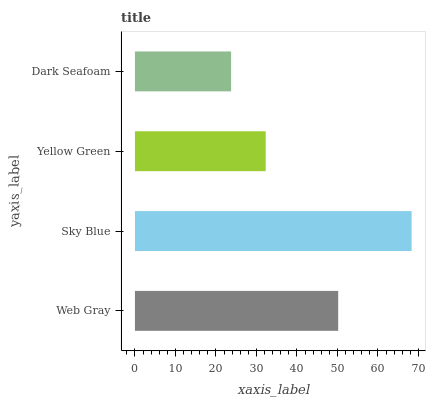Is Dark Seafoam the minimum?
Answer yes or no. Yes. Is Sky Blue the maximum?
Answer yes or no. Yes. Is Yellow Green the minimum?
Answer yes or no. No. Is Yellow Green the maximum?
Answer yes or no. No. Is Sky Blue greater than Yellow Green?
Answer yes or no. Yes. Is Yellow Green less than Sky Blue?
Answer yes or no. Yes. Is Yellow Green greater than Sky Blue?
Answer yes or no. No. Is Sky Blue less than Yellow Green?
Answer yes or no. No. Is Web Gray the high median?
Answer yes or no. Yes. Is Yellow Green the low median?
Answer yes or no. Yes. Is Dark Seafoam the high median?
Answer yes or no. No. Is Web Gray the low median?
Answer yes or no. No. 